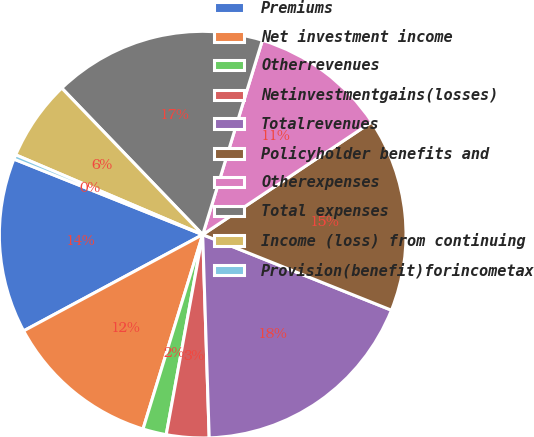<chart> <loc_0><loc_0><loc_500><loc_500><pie_chart><fcel>Premiums<fcel>Net investment income<fcel>Otherrevenues<fcel>Netinvestmentgains(losses)<fcel>Totalrevenues<fcel>Policyholder benefits and<fcel>Otherexpenses<fcel>Total expenses<fcel>Income (loss) from continuing<fcel>Provision(benefit)forincometax<nl><fcel>13.91%<fcel>12.41%<fcel>1.87%<fcel>3.38%<fcel>18.43%<fcel>15.42%<fcel>10.9%<fcel>16.93%<fcel>6.39%<fcel>0.36%<nl></chart> 